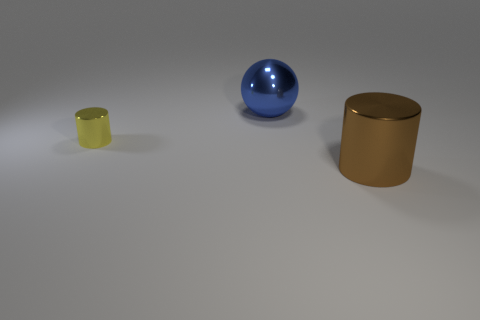There is a large shiny object right of the big metallic thing that is on the left side of the thing that is in front of the tiny yellow cylinder; what shape is it?
Your answer should be very brief. Cylinder. There is a metal cylinder that is the same size as the blue shiny thing; what is its color?
Ensure brevity in your answer.  Brown. How many other things are there of the same shape as the blue shiny thing?
Your response must be concise. 0. Do the blue sphere and the yellow object have the same size?
Keep it short and to the point. No. Is the number of large blue metallic objects that are in front of the yellow metal cylinder greater than the number of large metal things in front of the large brown cylinder?
Your response must be concise. No. How many other things are the same size as the yellow metal cylinder?
Your answer should be very brief. 0. There is a cylinder that is in front of the yellow object; does it have the same color as the big sphere?
Give a very brief answer. No. Are there more big brown shiny cylinders behind the large brown thing than shiny cylinders?
Your answer should be compact. No. Is there anything else that is the same color as the tiny metallic object?
Make the answer very short. No. There is a object in front of the cylinder on the left side of the big brown thing; what is its shape?
Offer a very short reply. Cylinder. 